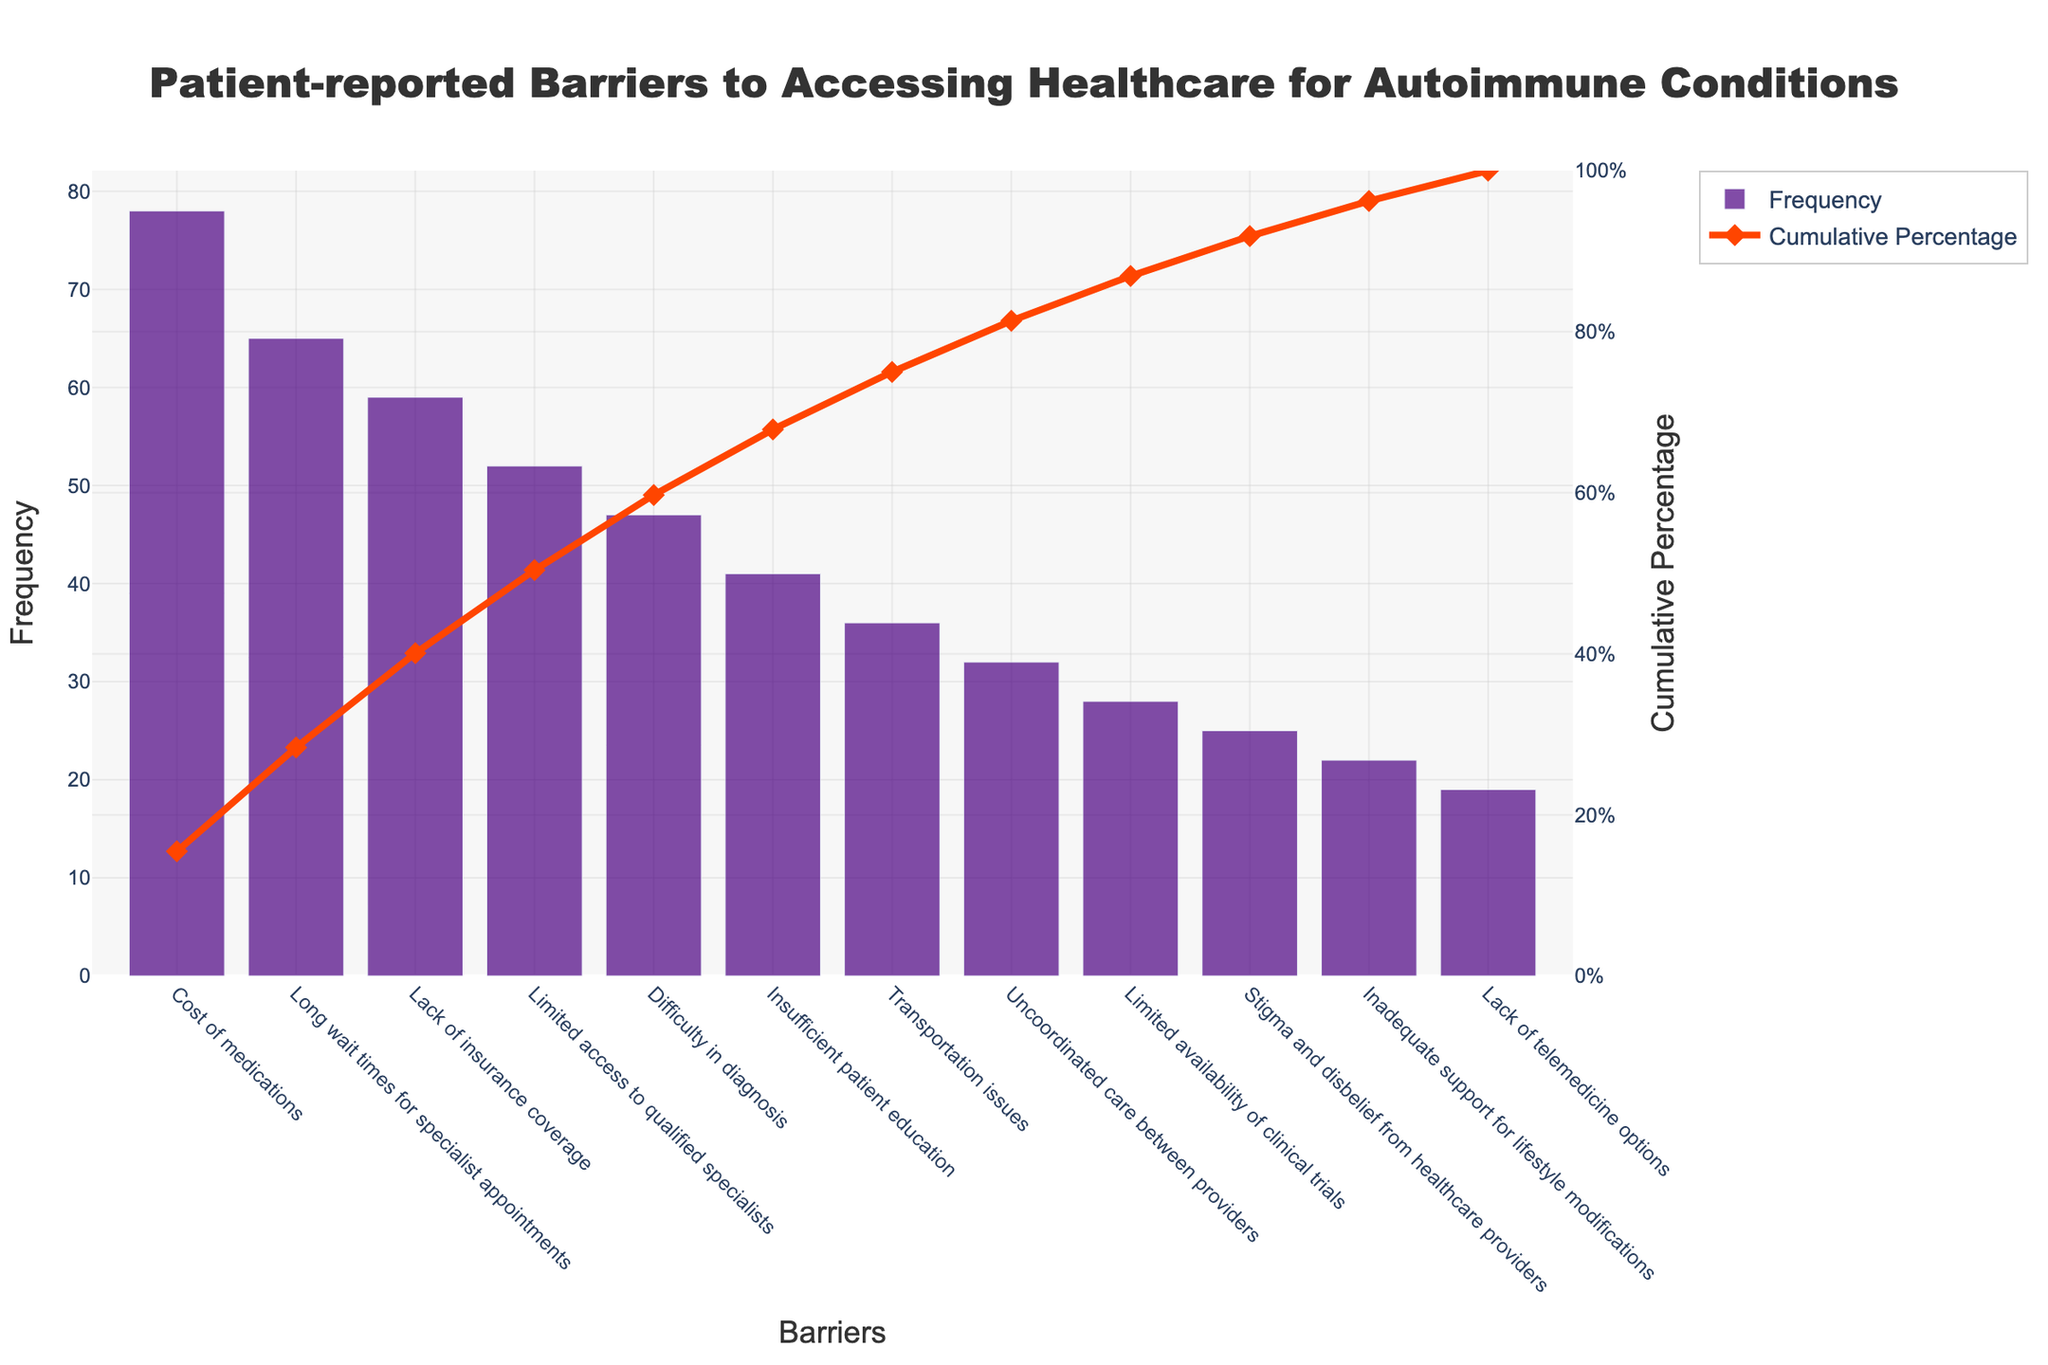How many barriers are listed in the figure? The figure lists each barrier as a point on the x-axis; by counting these points, we can determine the total number of barriers listed.
Answer: 12 What is the title of the figure? The title is typically placed at the top of the figure, immediately conveying the primary focus of the data shown.
Answer: Patient-reported Barriers to Accessing Healthcare for Autoimmune Conditions Which barrier has the highest frequency? By examining the heights of the bars, the tallest bar indicates the barrier with the highest frequency.
Answer: Cost of medications What is the cumulative percentage for the last barrier on the list? The cumulative percentage line reaches its maximum at the last point, which corresponds to the last barrier listed on the x-axis.
Answer: 100% Which barriers have a cumulative percentage of over 50%? To find these barriers, look at the points on the x-axis where the cumulative percentage line crosses above 50%. Identify the barriers up to this point.
Answer: Cost of medications, Long wait times for specialist appointments, Lack of insurance coverage What is the cumulative frequency for the first three barriers combined? First, add the frequencies of the three highest barriers (78 + 65 + 59). Then, to convert to a cumulative frequency, sum these frequencies.
Answer: 202 Compare the frequency of "Long wait times for specialist appointments" to "Lack of insurance coverage." Identify the heights of the respective bars and compare which one is taller.
Answer: Long wait times for specialist appointments is higher than Lack of insurance coverage At what cumulative percentage does "Limited access to qualified specialists" appear? Locate the barrier "Limited access to qualified specialists" on the x-axis and note the corresponding value of the cumulative percentage line.
Answer: Approximately 66% Which barrier has the lowest frequency, and what is its frequency? The shortest bar indicates the barrier with the lowest frequency. By identifying and reading the value, we can find the answer.
Answer: Lack of telemedicine options, 19 By how much does the frequency of "Cost of medications" exceed "Long wait times for specialist appointments"? Subtract the frequency of "Long wait times for specialist appointments" from "Cost of medications" (78 - 65).
Answer: 13 Percentage-wise, what share of the cumulative barrier is represented by "Difficulty in diagnosis"? Find the cumulative percentage value at the point of "Difficulty in diagnosis". This is represented by its position on the cumulative line graph.
Answer: Approximately 67% 